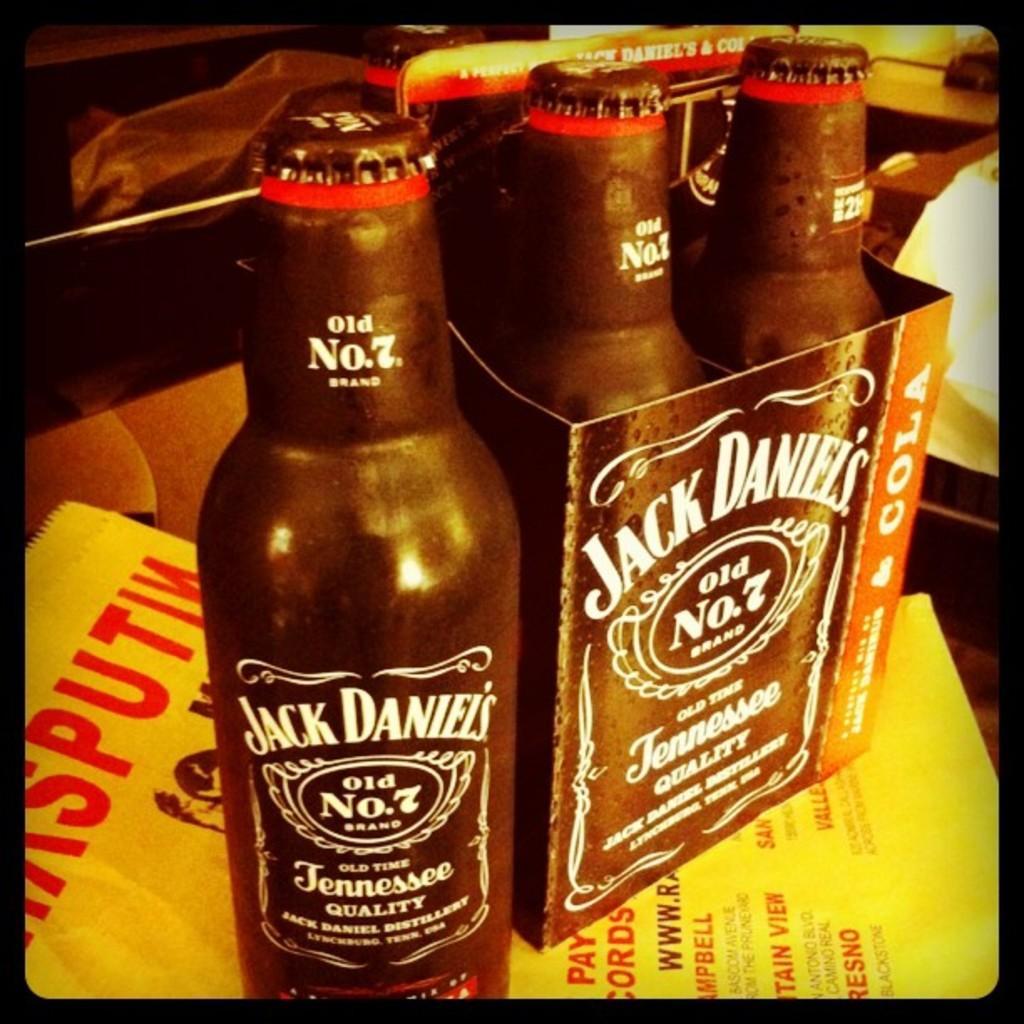Could you give a brief overview of what you see in this image? In this image there are bottles with some text written on it and there is a paper which is yellow in colour with some text written on it. 